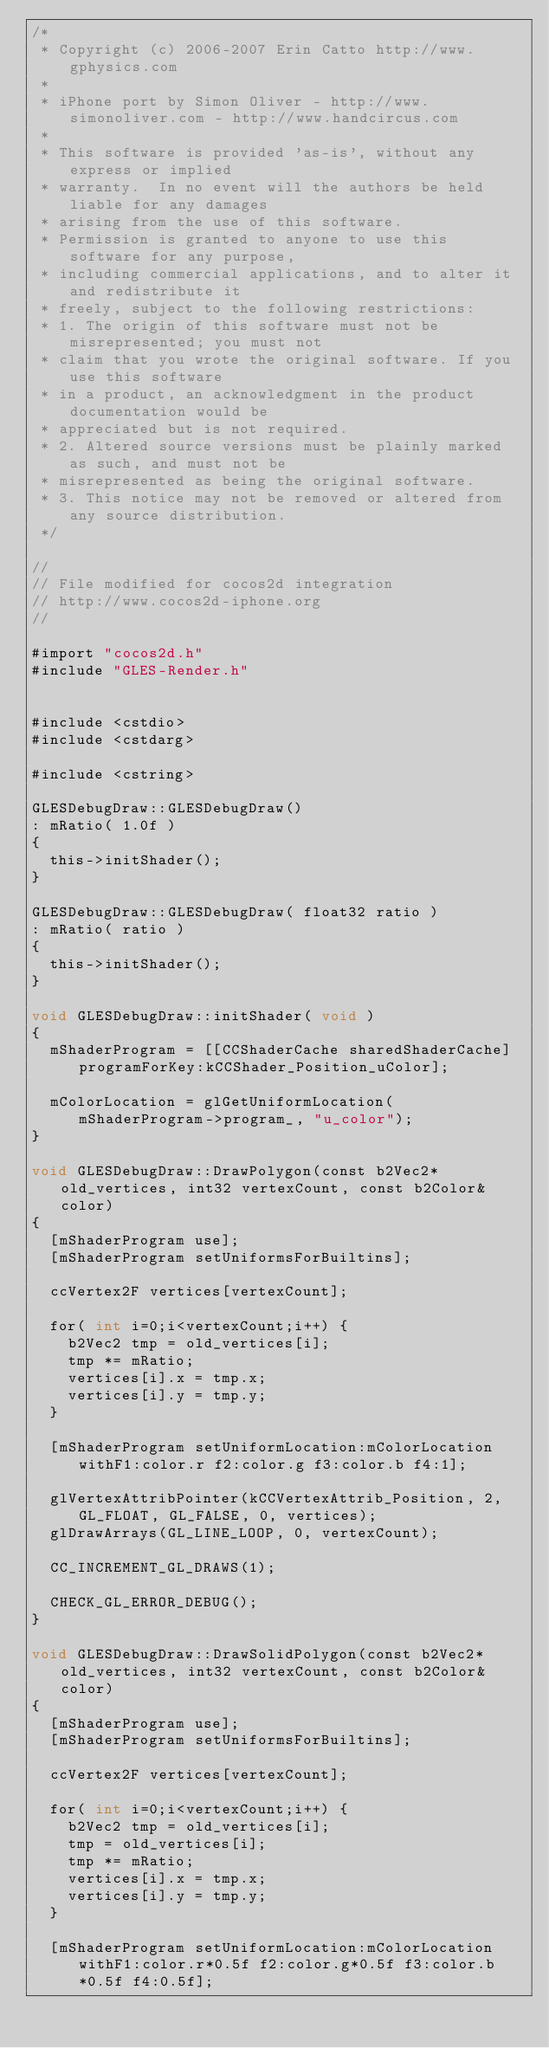<code> <loc_0><loc_0><loc_500><loc_500><_ObjectiveC_>/*
 * Copyright (c) 2006-2007 Erin Catto http://www.gphysics.com
 *
 * iPhone port by Simon Oliver - http://www.simonoliver.com - http://www.handcircus.com
 *
 * This software is provided 'as-is', without any express or implied
 * warranty.  In no event will the authors be held liable for any damages
 * arising from the use of this software.
 * Permission is granted to anyone to use this software for any purpose,
 * including commercial applications, and to alter it and redistribute it
 * freely, subject to the following restrictions:
 * 1. The origin of this software must not be misrepresented; you must not
 * claim that you wrote the original software. If you use this software
 * in a product, an acknowledgment in the product documentation would be
 * appreciated but is not required.
 * 2. Altered source versions must be plainly marked as such, and must not be
 * misrepresented as being the original software.
 * 3. This notice may not be removed or altered from any source distribution.
 */

//
// File modified for cocos2d integration
// http://www.cocos2d-iphone.org
//

#import "cocos2d.h"
#include "GLES-Render.h"


#include <cstdio>
#include <cstdarg>

#include <cstring>

GLESDebugDraw::GLESDebugDraw()
: mRatio( 1.0f )
{
	this->initShader();
}

GLESDebugDraw::GLESDebugDraw( float32 ratio )
: mRatio( ratio )
{
	this->initShader();
}

void GLESDebugDraw::initShader( void )
{
	mShaderProgram = [[CCShaderCache sharedShaderCache] programForKey:kCCShader_Position_uColor];

	mColorLocation = glGetUniformLocation( mShaderProgram->program_, "u_color");
}

void GLESDebugDraw::DrawPolygon(const b2Vec2* old_vertices, int32 vertexCount, const b2Color& color)
{
	[mShaderProgram use];
	[mShaderProgram setUniformsForBuiltins];

	ccVertex2F vertices[vertexCount];

	for( int i=0;i<vertexCount;i++) {
		b2Vec2 tmp = old_vertices[i];
		tmp *= mRatio;
		vertices[i].x = tmp.x;
		vertices[i].y = tmp.y;
	}

	[mShaderProgram setUniformLocation:mColorLocation withF1:color.r f2:color.g f3:color.b f4:1];

	glVertexAttribPointer(kCCVertexAttrib_Position, 2, GL_FLOAT, GL_FALSE, 0, vertices);
	glDrawArrays(GL_LINE_LOOP, 0, vertexCount);

	CC_INCREMENT_GL_DRAWS(1);

	CHECK_GL_ERROR_DEBUG();
}

void GLESDebugDraw::DrawSolidPolygon(const b2Vec2* old_vertices, int32 vertexCount, const b2Color& color)
{
	[mShaderProgram use];
	[mShaderProgram setUniformsForBuiltins];

	ccVertex2F vertices[vertexCount];

	for( int i=0;i<vertexCount;i++) {
		b2Vec2 tmp = old_vertices[i];
		tmp = old_vertices[i];
		tmp *= mRatio;
		vertices[i].x = tmp.x;
		vertices[i].y = tmp.y;
	}

	[mShaderProgram setUniformLocation:mColorLocation withF1:color.r*0.5f f2:color.g*0.5f f3:color.b*0.5f f4:0.5f];
</code> 